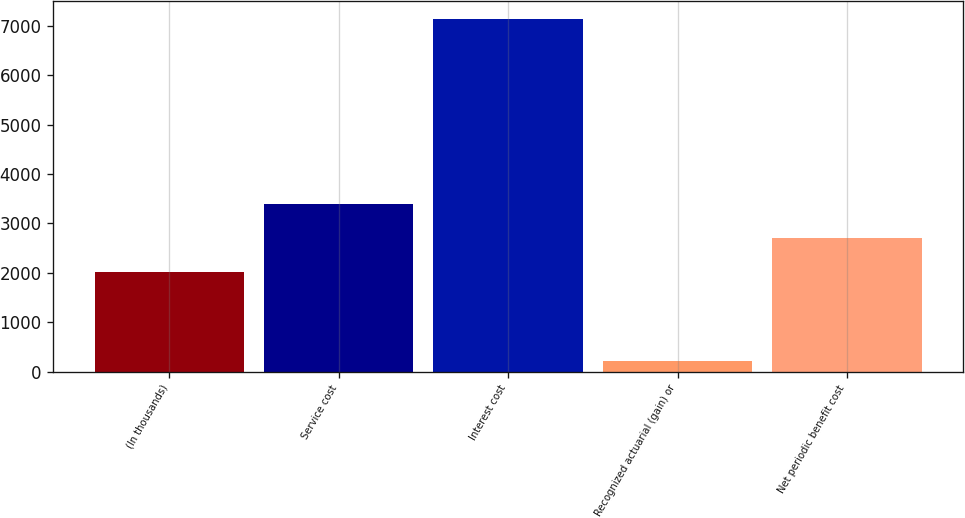<chart> <loc_0><loc_0><loc_500><loc_500><bar_chart><fcel>(In thousands)<fcel>Service cost<fcel>Interest cost<fcel>Recognized actuarial (gain) or<fcel>Net periodic benefit cost<nl><fcel>2007<fcel>3394.6<fcel>7144<fcel>206<fcel>2700.8<nl></chart> 